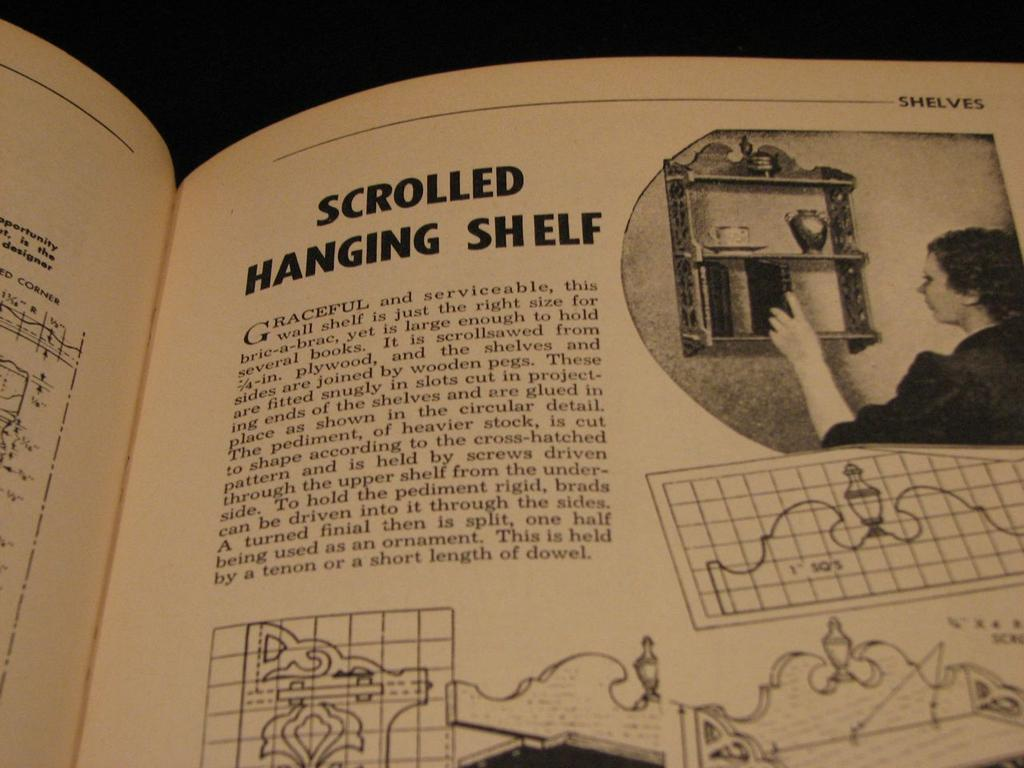<image>
Create a compact narrative representing the image presented. A catalog is open to a scrolled hanging shelf product. 